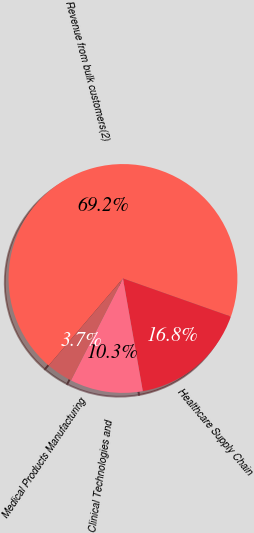Convert chart. <chart><loc_0><loc_0><loc_500><loc_500><pie_chart><fcel>Revenue from bulk customers(2)<fcel>Healthcare Supply Chain<fcel>Clinical Technologies and<fcel>Medical Products Manufacturing<nl><fcel>69.15%<fcel>16.82%<fcel>10.28%<fcel>3.74%<nl></chart> 